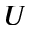<formula> <loc_0><loc_0><loc_500><loc_500>U</formula> 